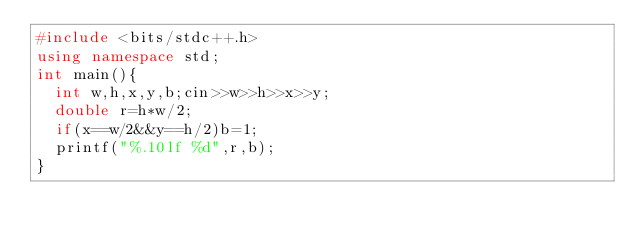<code> <loc_0><loc_0><loc_500><loc_500><_C++_>#include <bits/stdc++.h>
using namespace std;
int main(){
  int w,h,x,y,b;cin>>w>>h>>x>>y;
  double r=h*w/2;
  if(x==w/2&&y==h/2)b=1;
  printf("%.10lf %d",r,b);
}</code> 